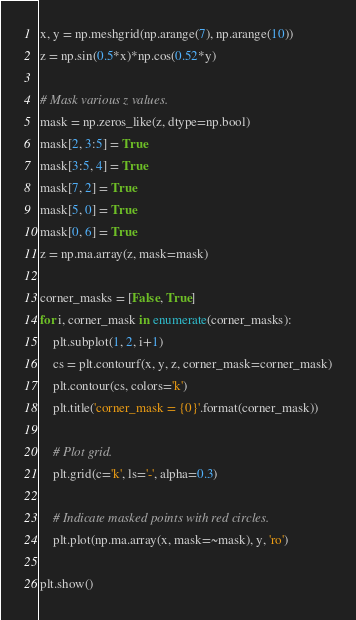Convert code to text. <code><loc_0><loc_0><loc_500><loc_500><_Python_>x, y = np.meshgrid(np.arange(7), np.arange(10))
z = np.sin(0.5*x)*np.cos(0.52*y)

# Mask various z values.
mask = np.zeros_like(z, dtype=np.bool)
mask[2, 3:5] = True
mask[3:5, 4] = True
mask[7, 2] = True
mask[5, 0] = True
mask[0, 6] = True
z = np.ma.array(z, mask=mask)

corner_masks = [False, True]
for i, corner_mask in enumerate(corner_masks):
    plt.subplot(1, 2, i+1)
    cs = plt.contourf(x, y, z, corner_mask=corner_mask)
    plt.contour(cs, colors='k')
    plt.title('corner_mask = {0}'.format(corner_mask))

    # Plot grid.
    plt.grid(c='k', ls='-', alpha=0.3)

    # Indicate masked points with red circles.
    plt.plot(np.ma.array(x, mask=~mask), y, 'ro')

plt.show()
</code> 